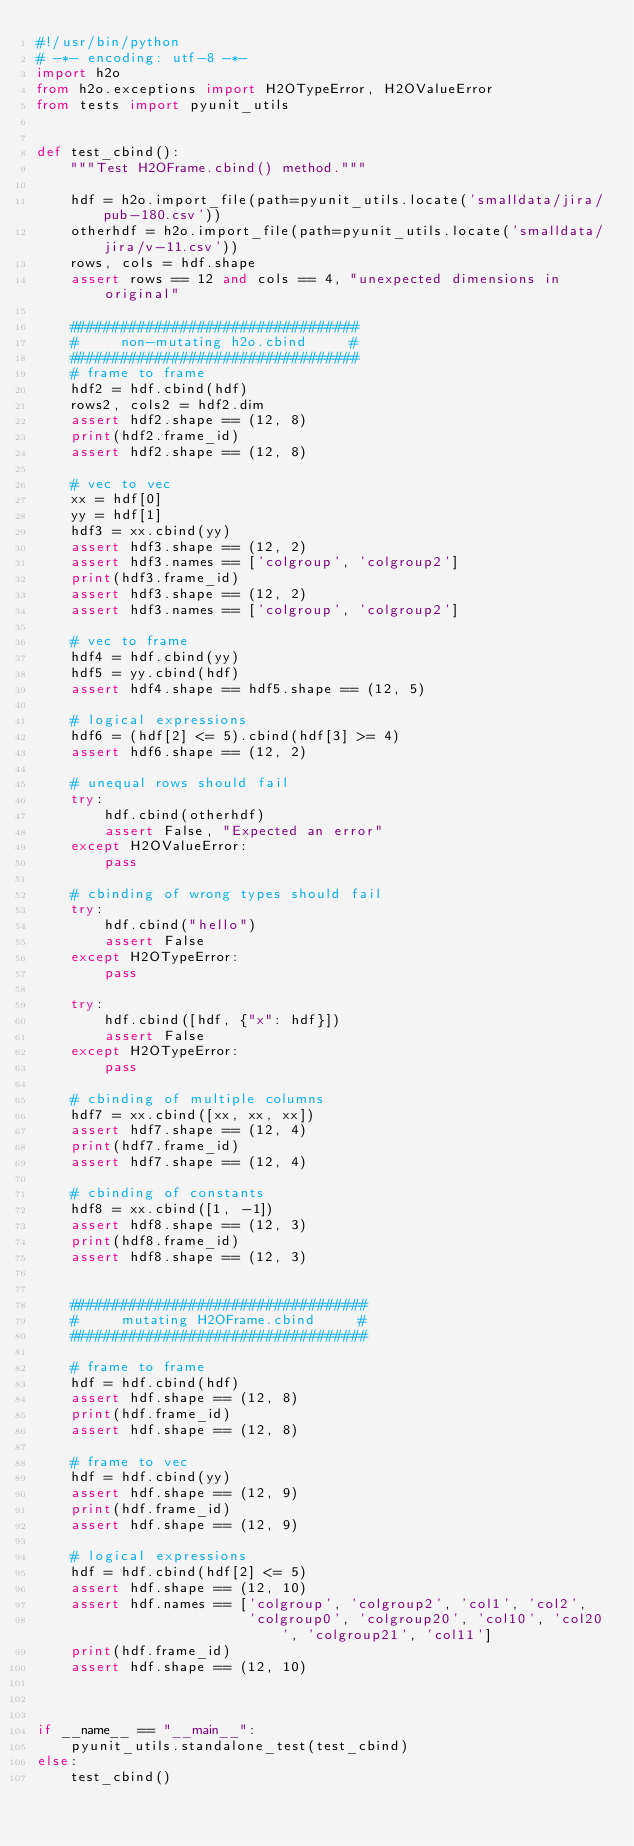<code> <loc_0><loc_0><loc_500><loc_500><_Python_>#!/usr/bin/python
# -*- encoding: utf-8 -*-
import h2o
from h2o.exceptions import H2OTypeError, H2OValueError
from tests import pyunit_utils


def test_cbind():
    """Test H2OFrame.cbind() method."""

    hdf = h2o.import_file(path=pyunit_utils.locate('smalldata/jira/pub-180.csv'))
    otherhdf = h2o.import_file(path=pyunit_utils.locate('smalldata/jira/v-11.csv'))
    rows, cols = hdf.shape
    assert rows == 12 and cols == 4, "unexpected dimensions in original"

    ##################################
    #     non-mutating h2o.cbind     #
    ##################################
    # frame to frame
    hdf2 = hdf.cbind(hdf)
    rows2, cols2 = hdf2.dim
    assert hdf2.shape == (12, 8)
    print(hdf2.frame_id)
    assert hdf2.shape == (12, 8)

    # vec to vec
    xx = hdf[0]
    yy = hdf[1]
    hdf3 = xx.cbind(yy)
    assert hdf3.shape == (12, 2)
    assert hdf3.names == ['colgroup', 'colgroup2']
    print(hdf3.frame_id)
    assert hdf3.shape == (12, 2)
    assert hdf3.names == ['colgroup', 'colgroup2']

    # vec to frame
    hdf4 = hdf.cbind(yy)
    hdf5 = yy.cbind(hdf)
    assert hdf4.shape == hdf5.shape == (12, 5)

    # logical expressions
    hdf6 = (hdf[2] <= 5).cbind(hdf[3] >= 4)
    assert hdf6.shape == (12, 2)

    # unequal rows should fail
    try:
        hdf.cbind(otherhdf)
        assert False, "Expected an error"
    except H2OValueError:
        pass

    # cbinding of wrong types should fail
    try:
        hdf.cbind("hello")
        assert False
    except H2OTypeError:
        pass

    try:
        hdf.cbind([hdf, {"x": hdf}])
        assert False
    except H2OTypeError:
        pass

    # cbinding of multiple columns
    hdf7 = xx.cbind([xx, xx, xx])
    assert hdf7.shape == (12, 4)
    print(hdf7.frame_id)
    assert hdf7.shape == (12, 4)

    # cbinding of constants
    hdf8 = xx.cbind([1, -1])
    assert hdf8.shape == (12, 3)
    print(hdf8.frame_id)
    assert hdf8.shape == (12, 3)


    ###################################
    #     mutating H2OFrame.cbind     #
    ###################################

    # frame to frame
    hdf = hdf.cbind(hdf)
    assert hdf.shape == (12, 8)
    print(hdf.frame_id)
    assert hdf.shape == (12, 8)

    # frame to vec
    hdf = hdf.cbind(yy)
    assert hdf.shape == (12, 9)
    print(hdf.frame_id)
    assert hdf.shape == (12, 9)

    # logical expressions
    hdf = hdf.cbind(hdf[2] <= 5)
    assert hdf.shape == (12, 10)
    assert hdf.names == ['colgroup', 'colgroup2', 'col1', 'col2',
                         'colgroup0', 'colgroup20', 'col10', 'col20', 'colgroup21', 'col11']
    print(hdf.frame_id)
    assert hdf.shape == (12, 10)



if __name__ == "__main__":
    pyunit_utils.standalone_test(test_cbind)
else:
    test_cbind()
</code> 